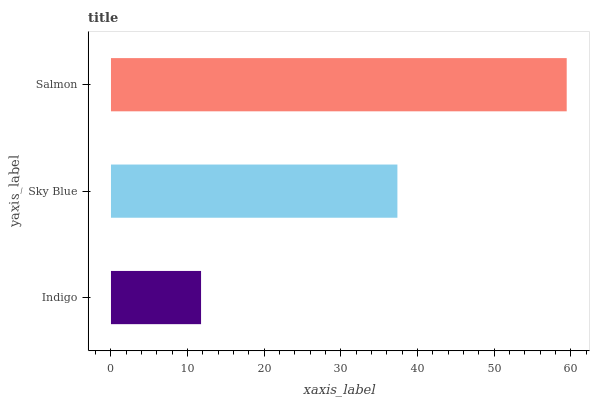Is Indigo the minimum?
Answer yes or no. Yes. Is Salmon the maximum?
Answer yes or no. Yes. Is Sky Blue the minimum?
Answer yes or no. No. Is Sky Blue the maximum?
Answer yes or no. No. Is Sky Blue greater than Indigo?
Answer yes or no. Yes. Is Indigo less than Sky Blue?
Answer yes or no. Yes. Is Indigo greater than Sky Blue?
Answer yes or no. No. Is Sky Blue less than Indigo?
Answer yes or no. No. Is Sky Blue the high median?
Answer yes or no. Yes. Is Sky Blue the low median?
Answer yes or no. Yes. Is Indigo the high median?
Answer yes or no. No. Is Salmon the low median?
Answer yes or no. No. 